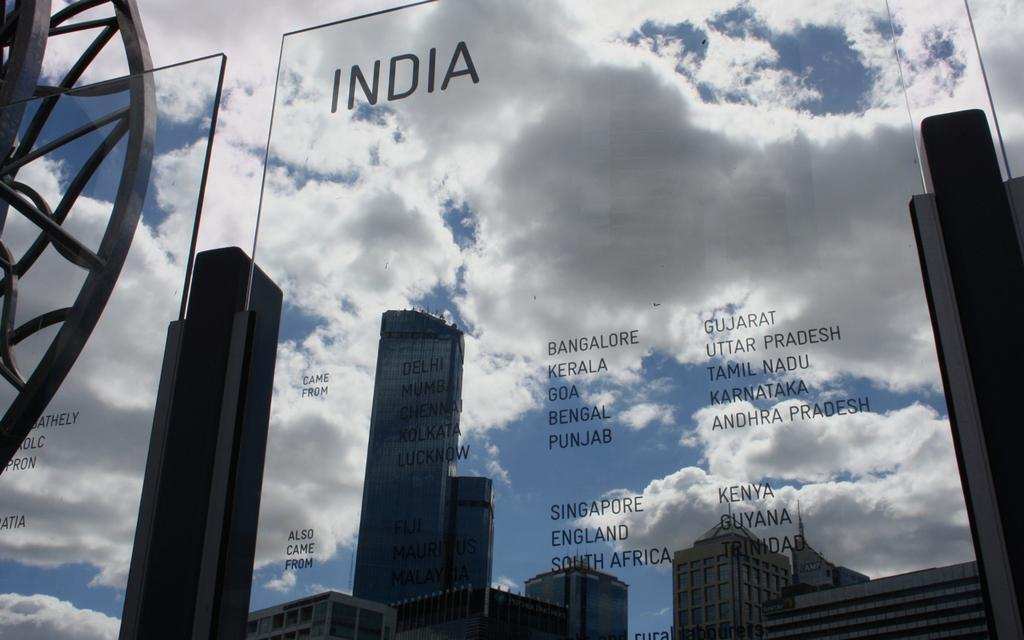How many glasses are present in the image? There are two glasses in the image. What is written on each glass? The names of states are written on each glass. What can be seen in the background of the image? Tall buildings are visible behind the glasses. Are there any tomatoes growing on the farm in the image? There is no farm or tomatoes present in the image; it features two glasses with state names and tall buildings in the background. 